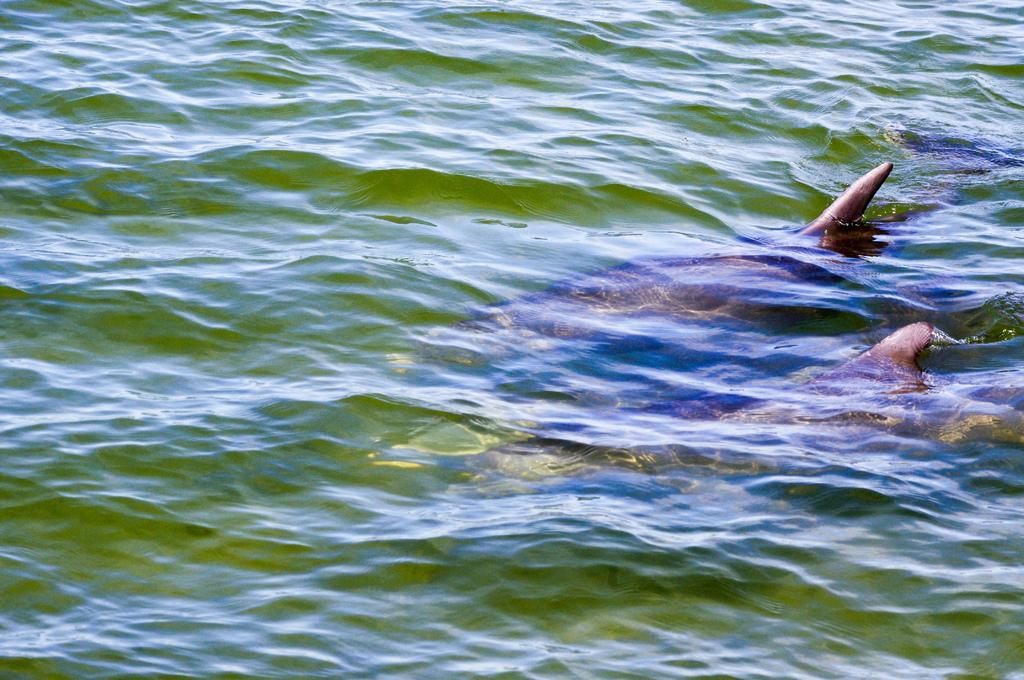Can you describe this image briefly? In this picture we can see water, it looks like a dolphin in the water. 